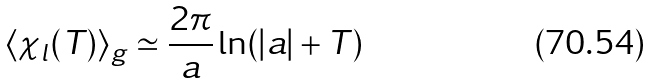<formula> <loc_0><loc_0><loc_500><loc_500>\langle \chi _ { l } ( T ) \rangle _ { g } \simeq \frac { 2 \pi } { a } \ln ( | a | + T )</formula> 